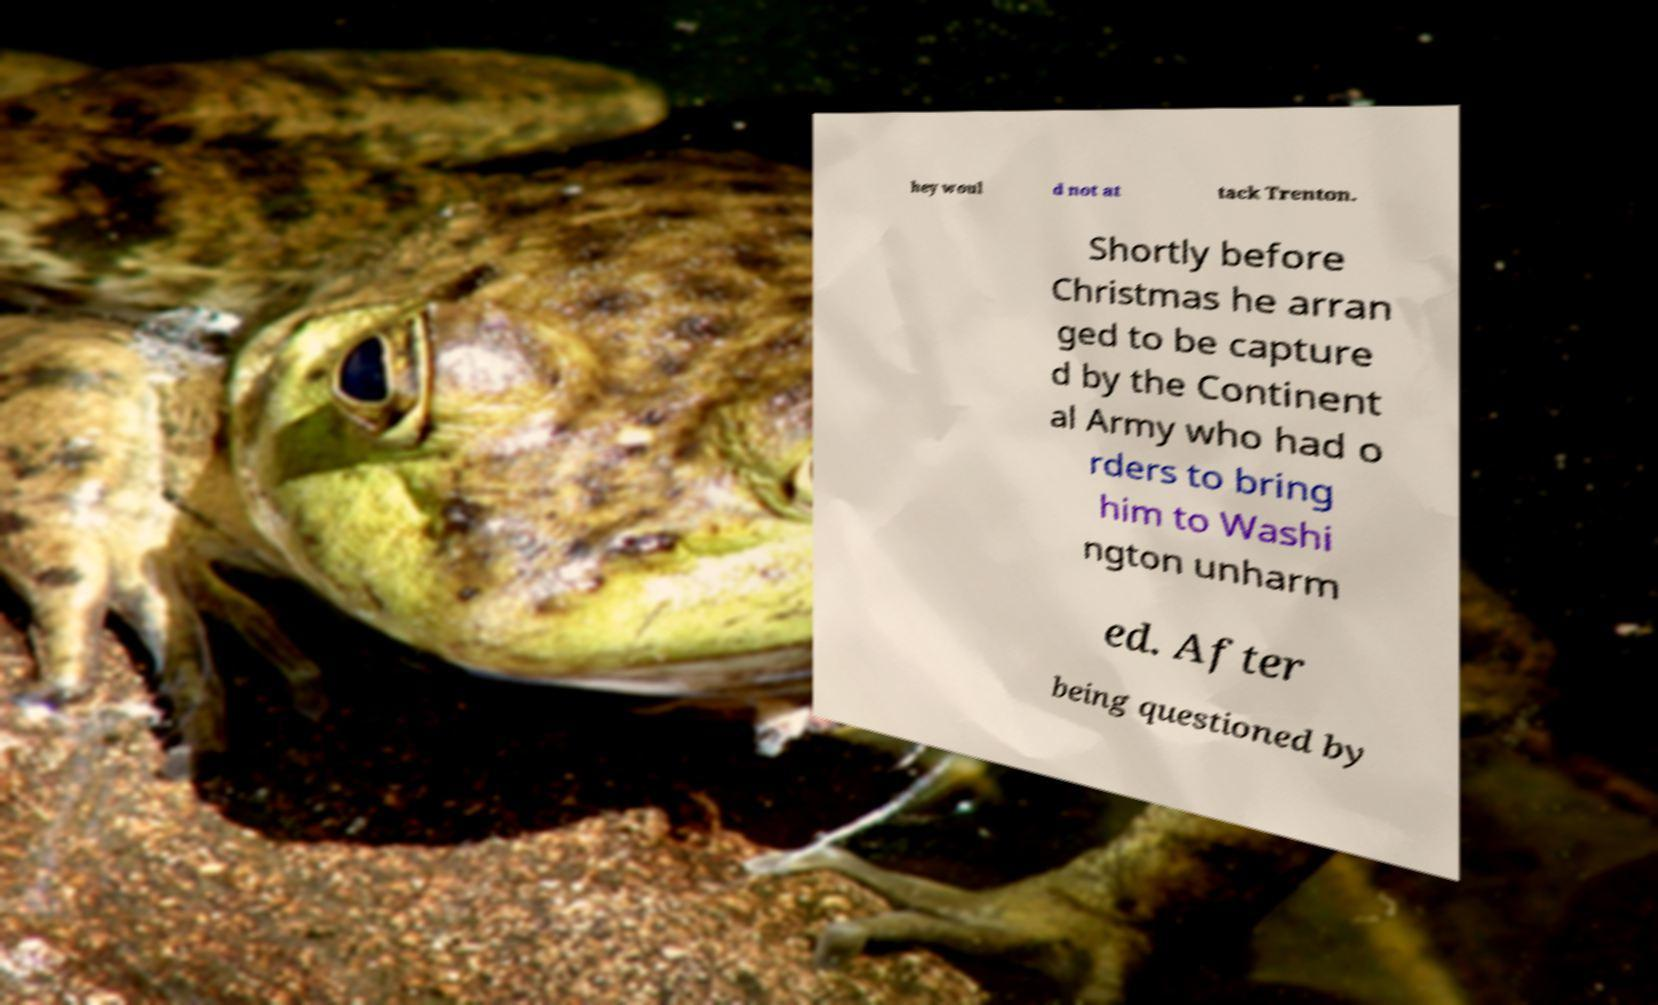Can you read and provide the text displayed in the image?This photo seems to have some interesting text. Can you extract and type it out for me? hey woul d not at tack Trenton. Shortly before Christmas he arran ged to be capture d by the Continent al Army who had o rders to bring him to Washi ngton unharm ed. After being questioned by 